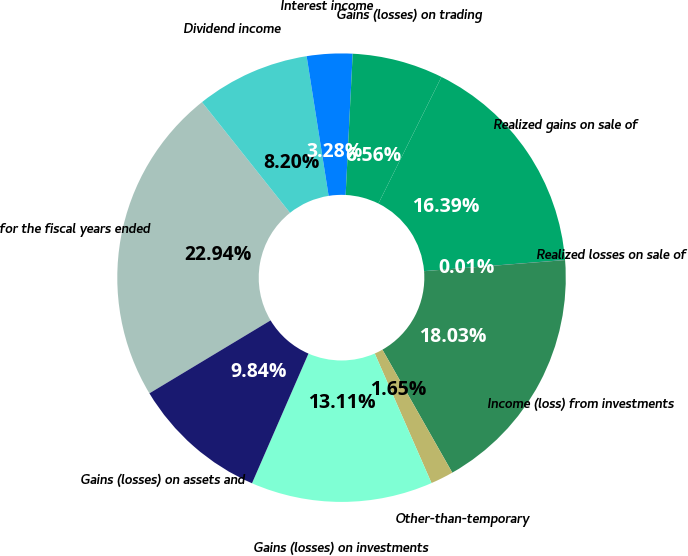Convert chart. <chart><loc_0><loc_0><loc_500><loc_500><pie_chart><fcel>for the fiscal years ended<fcel>Dividend income<fcel>Interest income<fcel>Gains (losses) on trading<fcel>Realized gains on sale of<fcel>Realized losses on sale of<fcel>Income (loss) from investments<fcel>Other-than-temporary<fcel>Gains (losses) on investments<fcel>Gains (losses) on assets and<nl><fcel>22.94%<fcel>8.2%<fcel>3.28%<fcel>6.56%<fcel>16.39%<fcel>0.01%<fcel>18.03%<fcel>1.65%<fcel>13.11%<fcel>9.84%<nl></chart> 